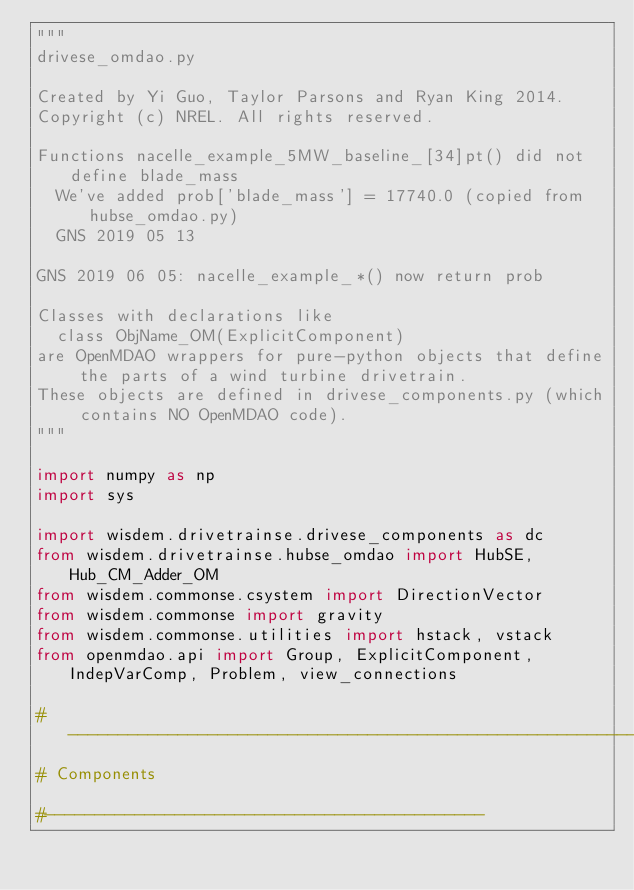Convert code to text. <code><loc_0><loc_0><loc_500><loc_500><_Python_>"""
drivese_omdao.py

Created by Yi Guo, Taylor Parsons and Ryan King 2014.
Copyright (c) NREL. All rights reserved.

Functions nacelle_example_5MW_baseline_[34]pt() did not define blade_mass
  We've added prob['blade_mass'] = 17740.0 (copied from hubse_omdao.py)
  GNS 2019 05 13
  
GNS 2019 06 05: nacelle_example_*() now return prob
  
Classes with declarations like
  class ObjName_OM(ExplicitComponent)
are OpenMDAO wrappers for pure-python objects that define the parts of a wind turbine drivetrain.
These objects are defined in drivese_components.py (which contains NO OpenMDAO code).
"""

import numpy as np
import sys

import wisdem.drivetrainse.drivese_components as dc
from wisdem.drivetrainse.hubse_omdao import HubSE, Hub_CM_Adder_OM
from wisdem.commonse.csystem import DirectionVector
from wisdem.commonse import gravity
from wisdem.commonse.utilities import hstack, vstack
from openmdao.api import Group, ExplicitComponent, IndepVarComp, Problem, view_connections

#-------------------------------------------------------------------------
# Components

#--------------------------------------------</code> 